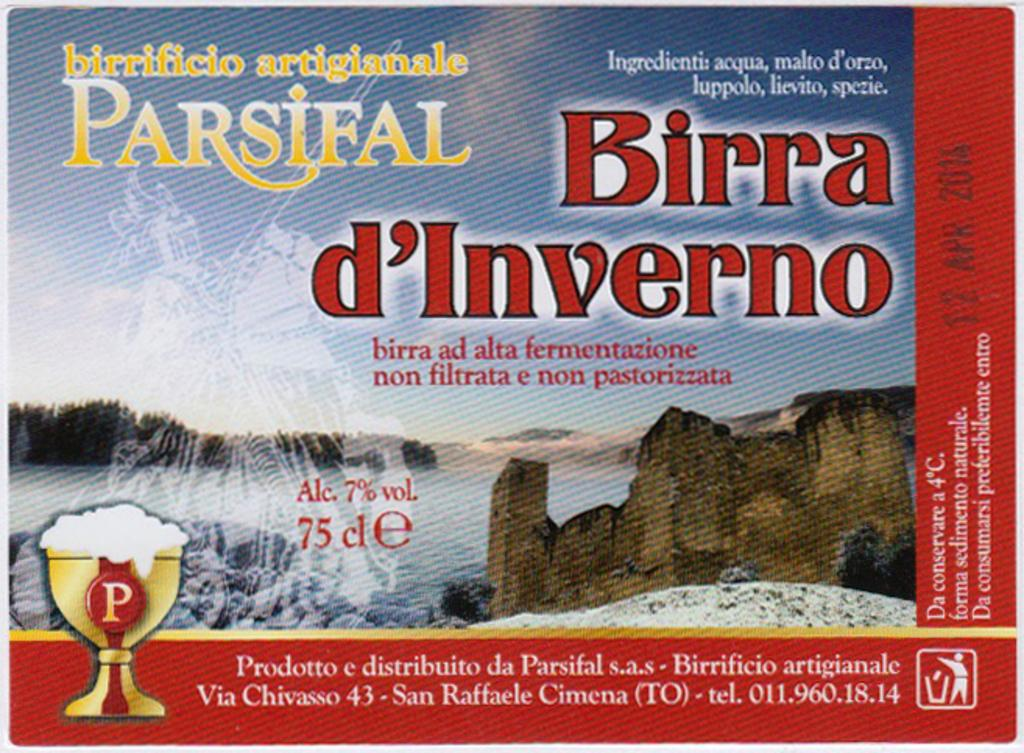What is featured on the poster in the image? The poster contains animated logos. What else can be seen on the poster besides the logos? There is text on the poster. What is visible in the background of the image? The sky, many trees, and a sea are visible in the image. Are there any other objects or features in the image? Yes, there are rocks in the image. What type of pot is the stranger holding in the image? There is no pot or stranger present in the image. How does the person in the image feel about their past decisions? The image does not convey any emotions or feelings, so it is impossible to determine if the person has any regrets. 